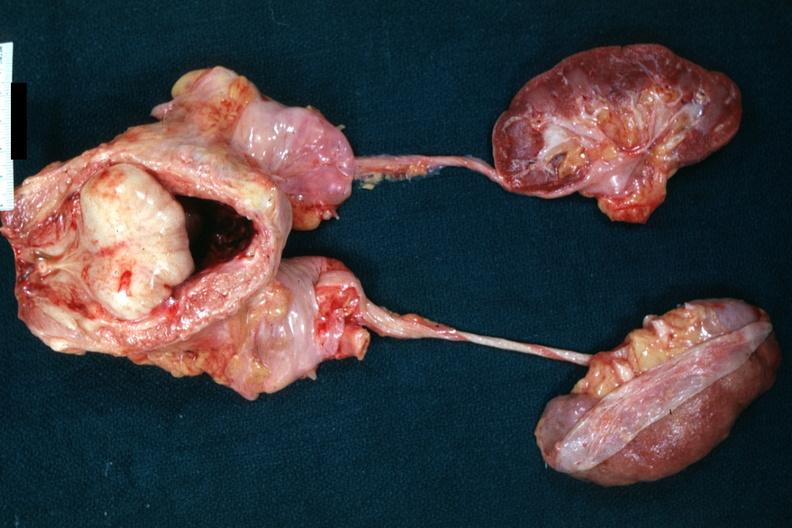s hyperplasia present?
Answer the question using a single word or phrase. Yes 